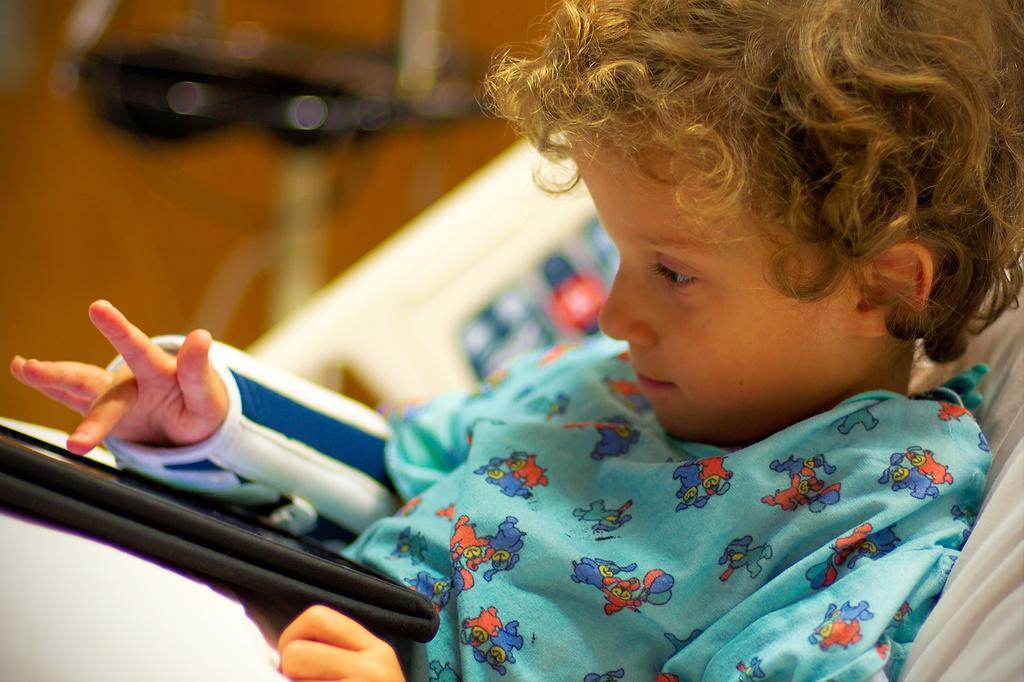Describe this image in one or two sentences. In this picture there is a kid on a bed, he is using an electronic gadget. The background is blurred. 